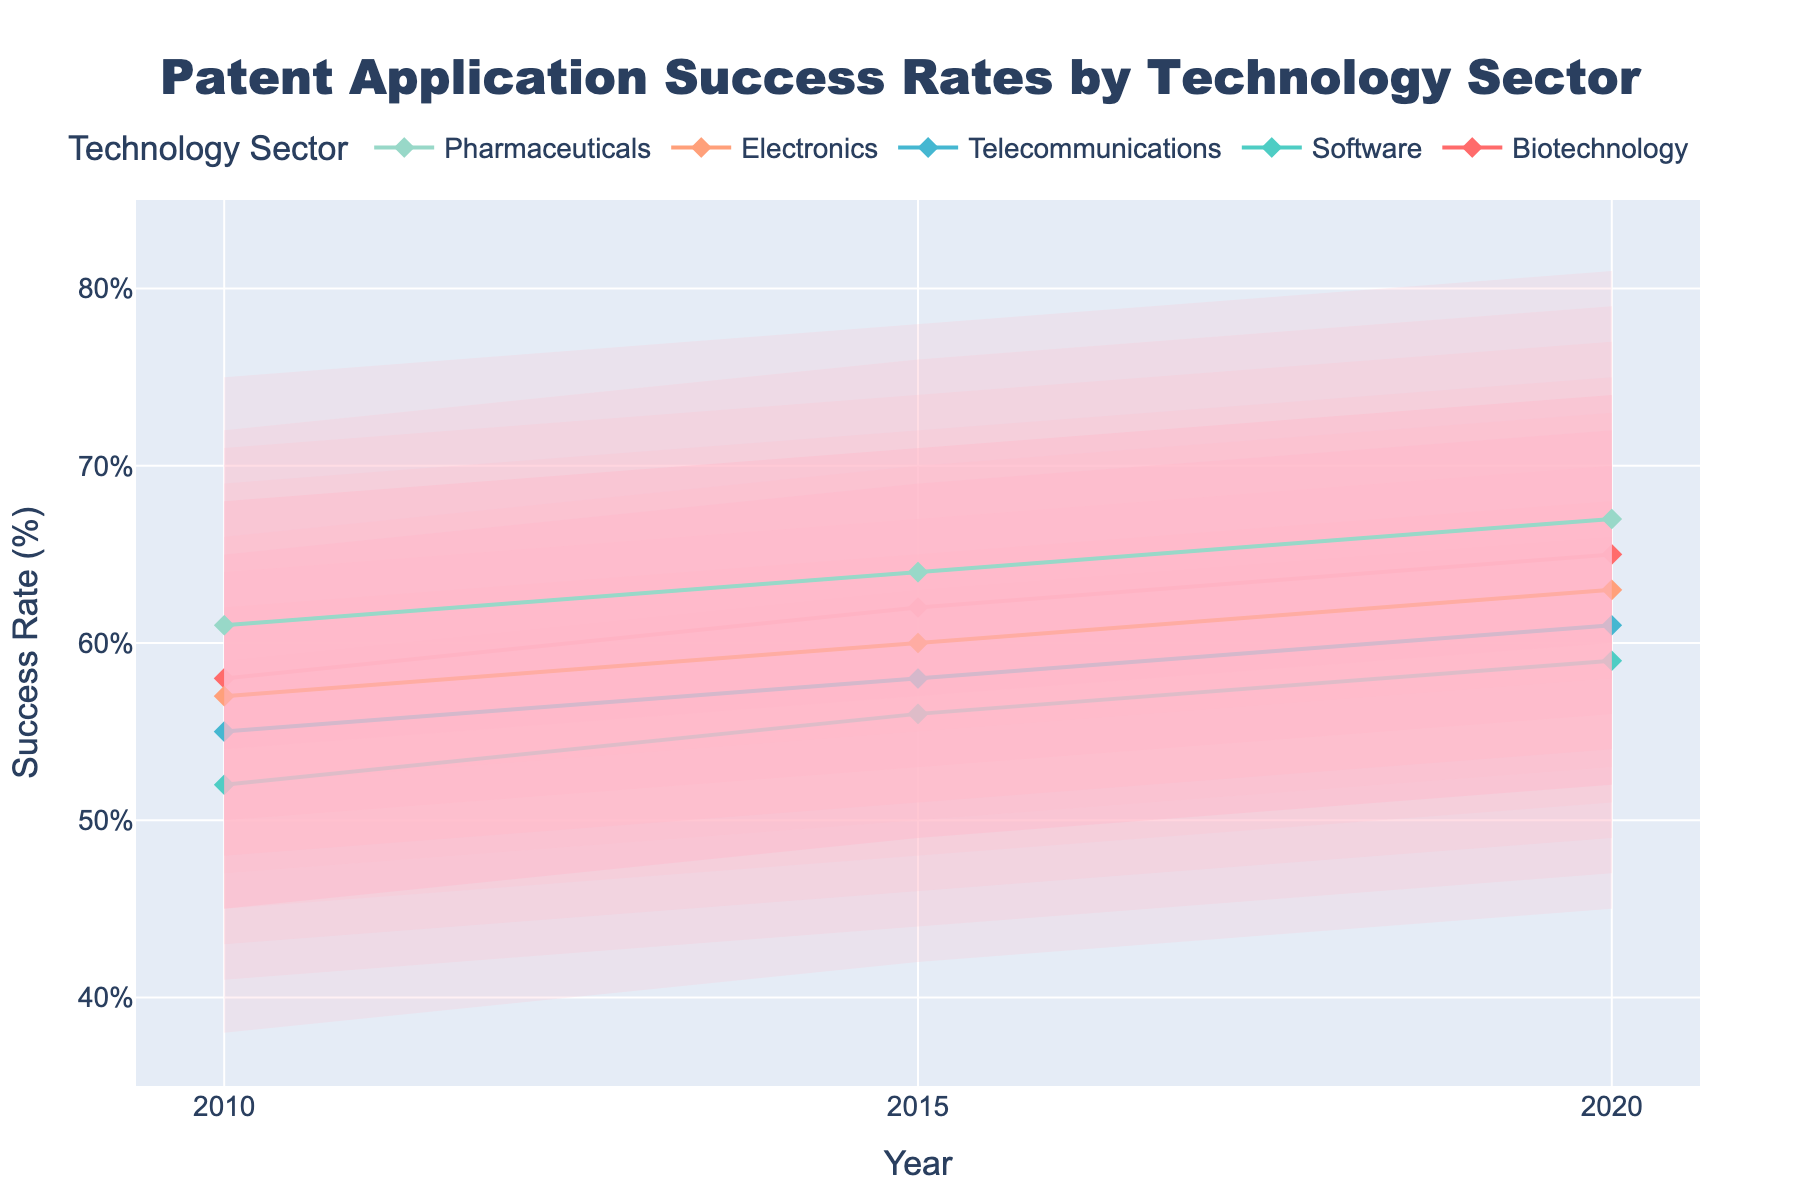What is the title of the figure? The title of the figure is located at the top of the chart, usually highlighted and larger in font size compared to other text elements.
Answer: Patent Application Success Rates by Technology Sector Which sector had the highest median success rate in 2010? To find the highest median success rate in 2010, look at the median values of all sectors for 2010 and identify the maximum value. According to the data, Pharmaceuticals had the highest median value of 61%.
Answer: Pharmaceuticals From 2010 to 2020, which sector showed the largest increase in the median success rate? Calculate the difference in the median success rate for each sector between 2020 and 2010, and find the sector with the largest difference. For Biotechnology, the increase is 65% - 58% = 7%; for Software, it's 59% - 52% = 7%; for Telecommunications, 61% - 55% = 6%; for Electronics, 63% - 57% = 6%; and for Pharmaceuticals, 67% - 61% = 6%. Thus, Biotechnology and Software both showed the largest increase of 7%.
Answer: Biotechnology, Software What is the range of the 10th percentile success rate for Pharmaceuticals in 2010? The range of a percentile is the difference between the maximum and minimum values provided for that year. For Pharmaceuticals in 2010, the 10th percentile success rates range is 47%.
Answer: 47% Which sector has the narrowest interquartile range (IQR) for the year 2020? IQR is the difference between the 75th and 25th percentiles. Calculate the IQR for each sector in 2020. Biotechnology: 72% - 58% = 14%; Software: 66% - 52% = 14%; Telecommunications: 68% - 54% = 14%; Electronics: 70% - 56% = 14%; Pharmaceuticals: 74% - 60% = 14%. Since all sectors have the same IQR of 14%, there is no single sector with the smallest IQR.
Answer: None, they are equal By how much did the 75th percentile success rate for Telecommunications change from 2010 to 2015? Subtract the 2010 value of the 75th percentile for Telecommunications from the 2015 value: 65% - 62% = 3%.
Answer: 3% Which technology sector consistently shows higher success rates across all percentiles for the given years? Compare the values of the 10th, 25th, median, 75th, and 90th percentiles across all years and sectors. Pharmaceuticals generally show higher values across all percentiles consistently.
Answer: Pharmaceuticals What is the average median success rate for Software over the years 2010, 2015, and 2020? Add up the median success rates for Software over the years and divide by the number of years: (52% + 56% + 59%) / 3 = 55.67%.
Answer: 55.67% Did any sector see a decline in the median success rate from 2015 to 2020? Check the median success rate for each sector in 2015 and 2020 to identify any declines: Biotechnology (62% to 65%), Software (56% to 59%), Telecommunications (58% to 61%), Electronics (60% to 63%), Pharmaceuticals (64% to 67%). Here, no sector shows a decline in the median success rate.
Answer: No 